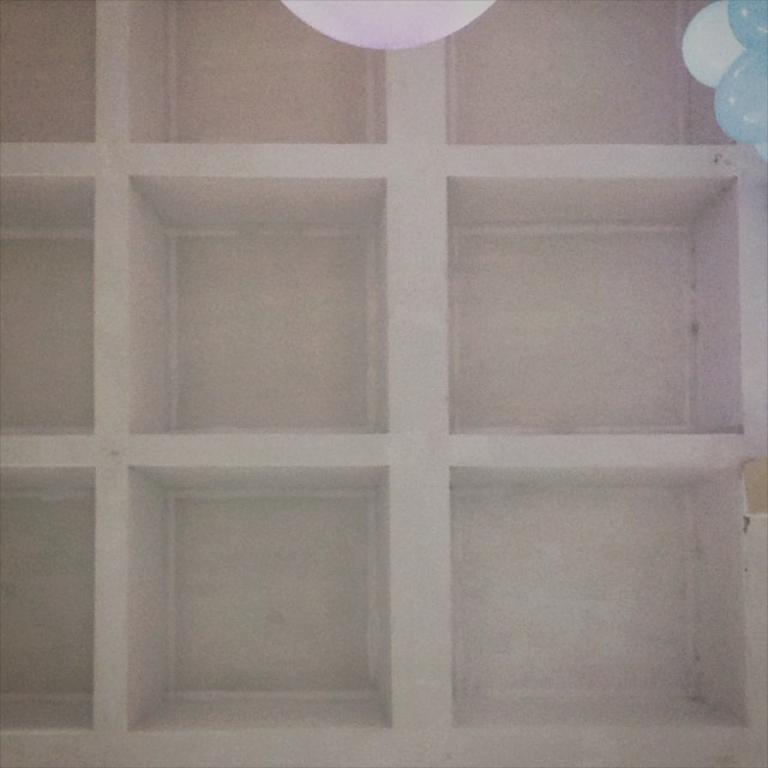What can be seen on the shelves in the image? The shelves in the image are empty. What else is visible in the image besides the empty shelves? There are balloons visible at the top of the image. How many cars are parked next to the shelves in the image? There are no cars present in the image; it only features empty shelves and balloons. 